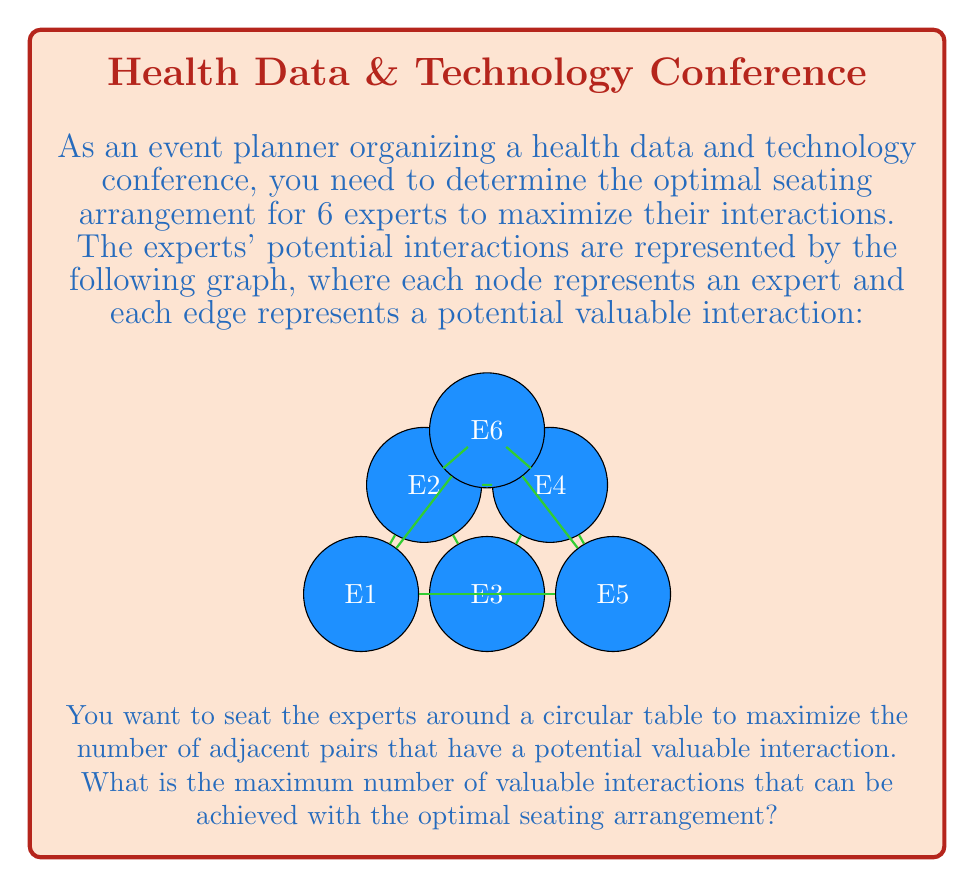Show me your answer to this math problem. To solve this problem, we need to find the maximum number of edges that can be represented by adjacent pairs in a circular arrangement. This is equivalent to finding the longest cycle in the graph, which is known as the Hamiltonian cycle problem.

Step 1: Identify all possible Hamiltonian cycles in the graph.
- E1-E2-E3-E4-E5-E6-E1
- E1-E2-E6-E5-E4-E3-E1
- E1-E6-E5-E4-E3-E2-E1

Step 2: Count the number of edges (valuable interactions) in each cycle.
- Cycle 1: E1-E2, E2-E3, E3-E4, E4-E5, E5-E6, E6-E1 (6 edges)
- Cycle 2: E1-E2, E2-E6, E6-E5, E5-E4, E4-E3, E3-E1 (6 edges)
- Cycle 3: E1-E6, E6-E5, E5-E4, E4-E3, E3-E2, E2-E1 (6 edges)

Step 3: Determine the maximum number of valuable interactions.
All cycles have 6 edges, which is the maximum possible for a 6-node graph.

Therefore, the optimal seating arrangement will result in 6 valuable interactions between adjacent experts.
Answer: 6 interactions 